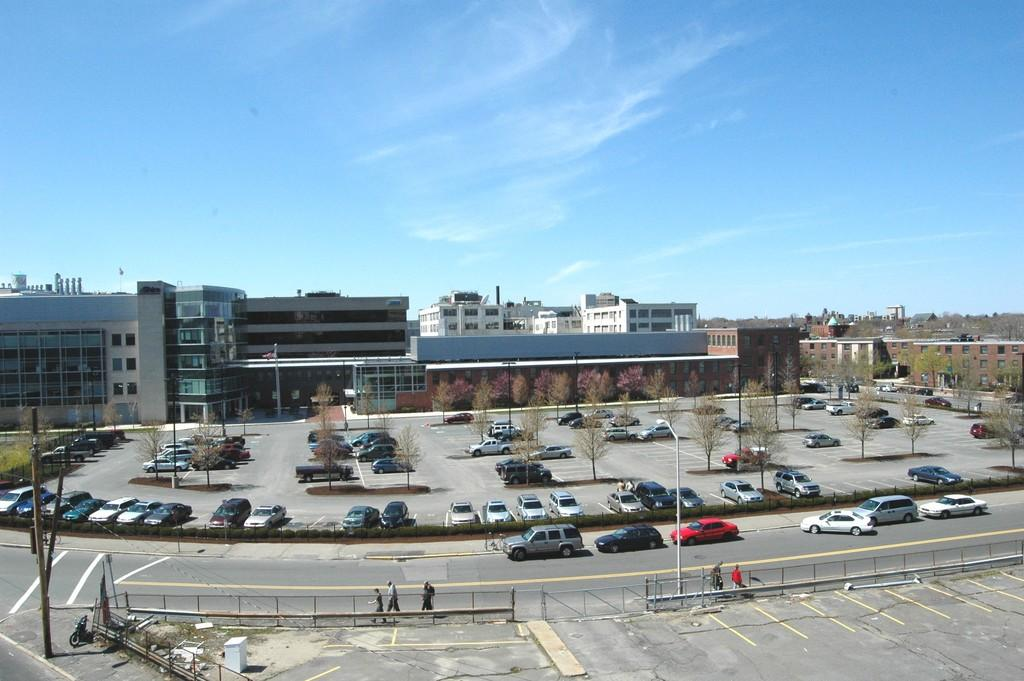What types of objects can be seen in the image? There are vehicles, roads, trees, poles, and people in the image. What structures are visible in the background of the image? There are buildings, walls, windows, and glass objects in the background of the image. What part of the natural environment is visible in the image? Trees are visible in the image. What is visible in the sky in the background of the image? The sky is visible in the background of the image. What type of thread is being used to create the crook in the image? There is no crook or thread present in the image. What color is the pencil being used by the person in the image? There is no pencil visible in the image. 